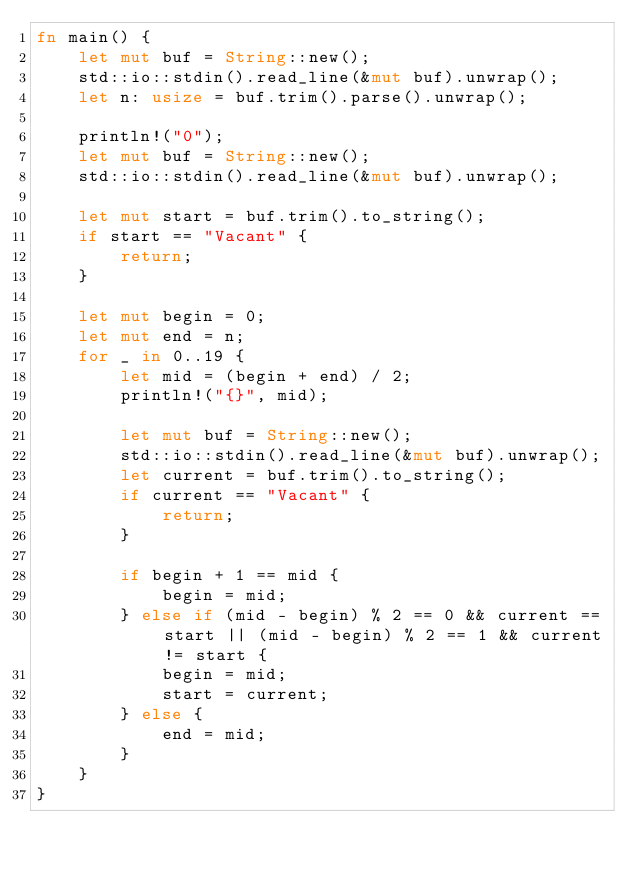<code> <loc_0><loc_0><loc_500><loc_500><_Rust_>fn main() {
    let mut buf = String::new();
    std::io::stdin().read_line(&mut buf).unwrap();
    let n: usize = buf.trim().parse().unwrap();

    println!("0");
    let mut buf = String::new();
    std::io::stdin().read_line(&mut buf).unwrap();

    let mut start = buf.trim().to_string();
    if start == "Vacant" {
        return;
    }

    let mut begin = 0;
    let mut end = n;
    for _ in 0..19 {
        let mid = (begin + end) / 2;
        println!("{}", mid);

        let mut buf = String::new();
        std::io::stdin().read_line(&mut buf).unwrap();
        let current = buf.trim().to_string();
        if current == "Vacant" {
            return;
        }

        if begin + 1 == mid {
            begin = mid;
        } else if (mid - begin) % 2 == 0 && current == start || (mid - begin) % 2 == 1 && current != start {
            begin = mid;
            start = current;
        } else {
            end = mid;
        }
    }
}
</code> 